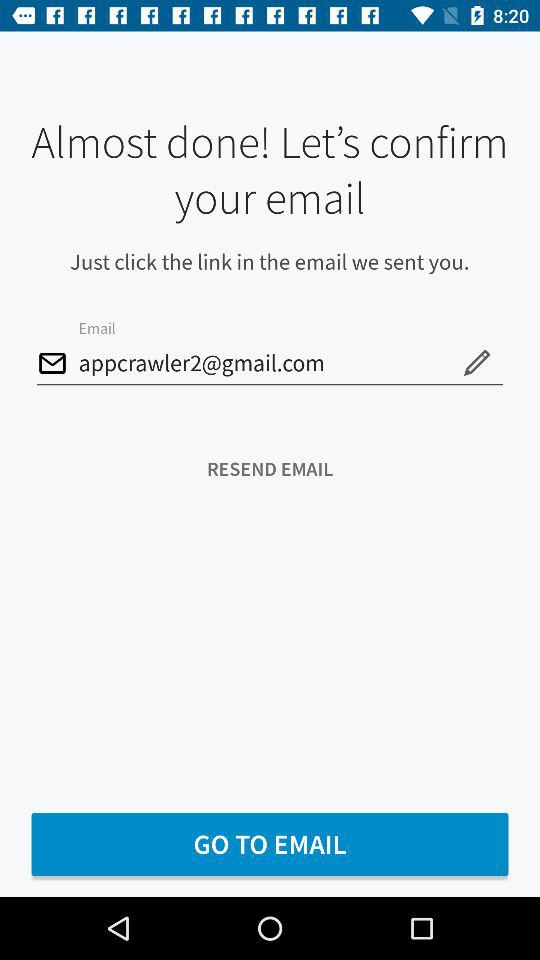What is the email address? The email address is appcrawler2@gmail.com. 